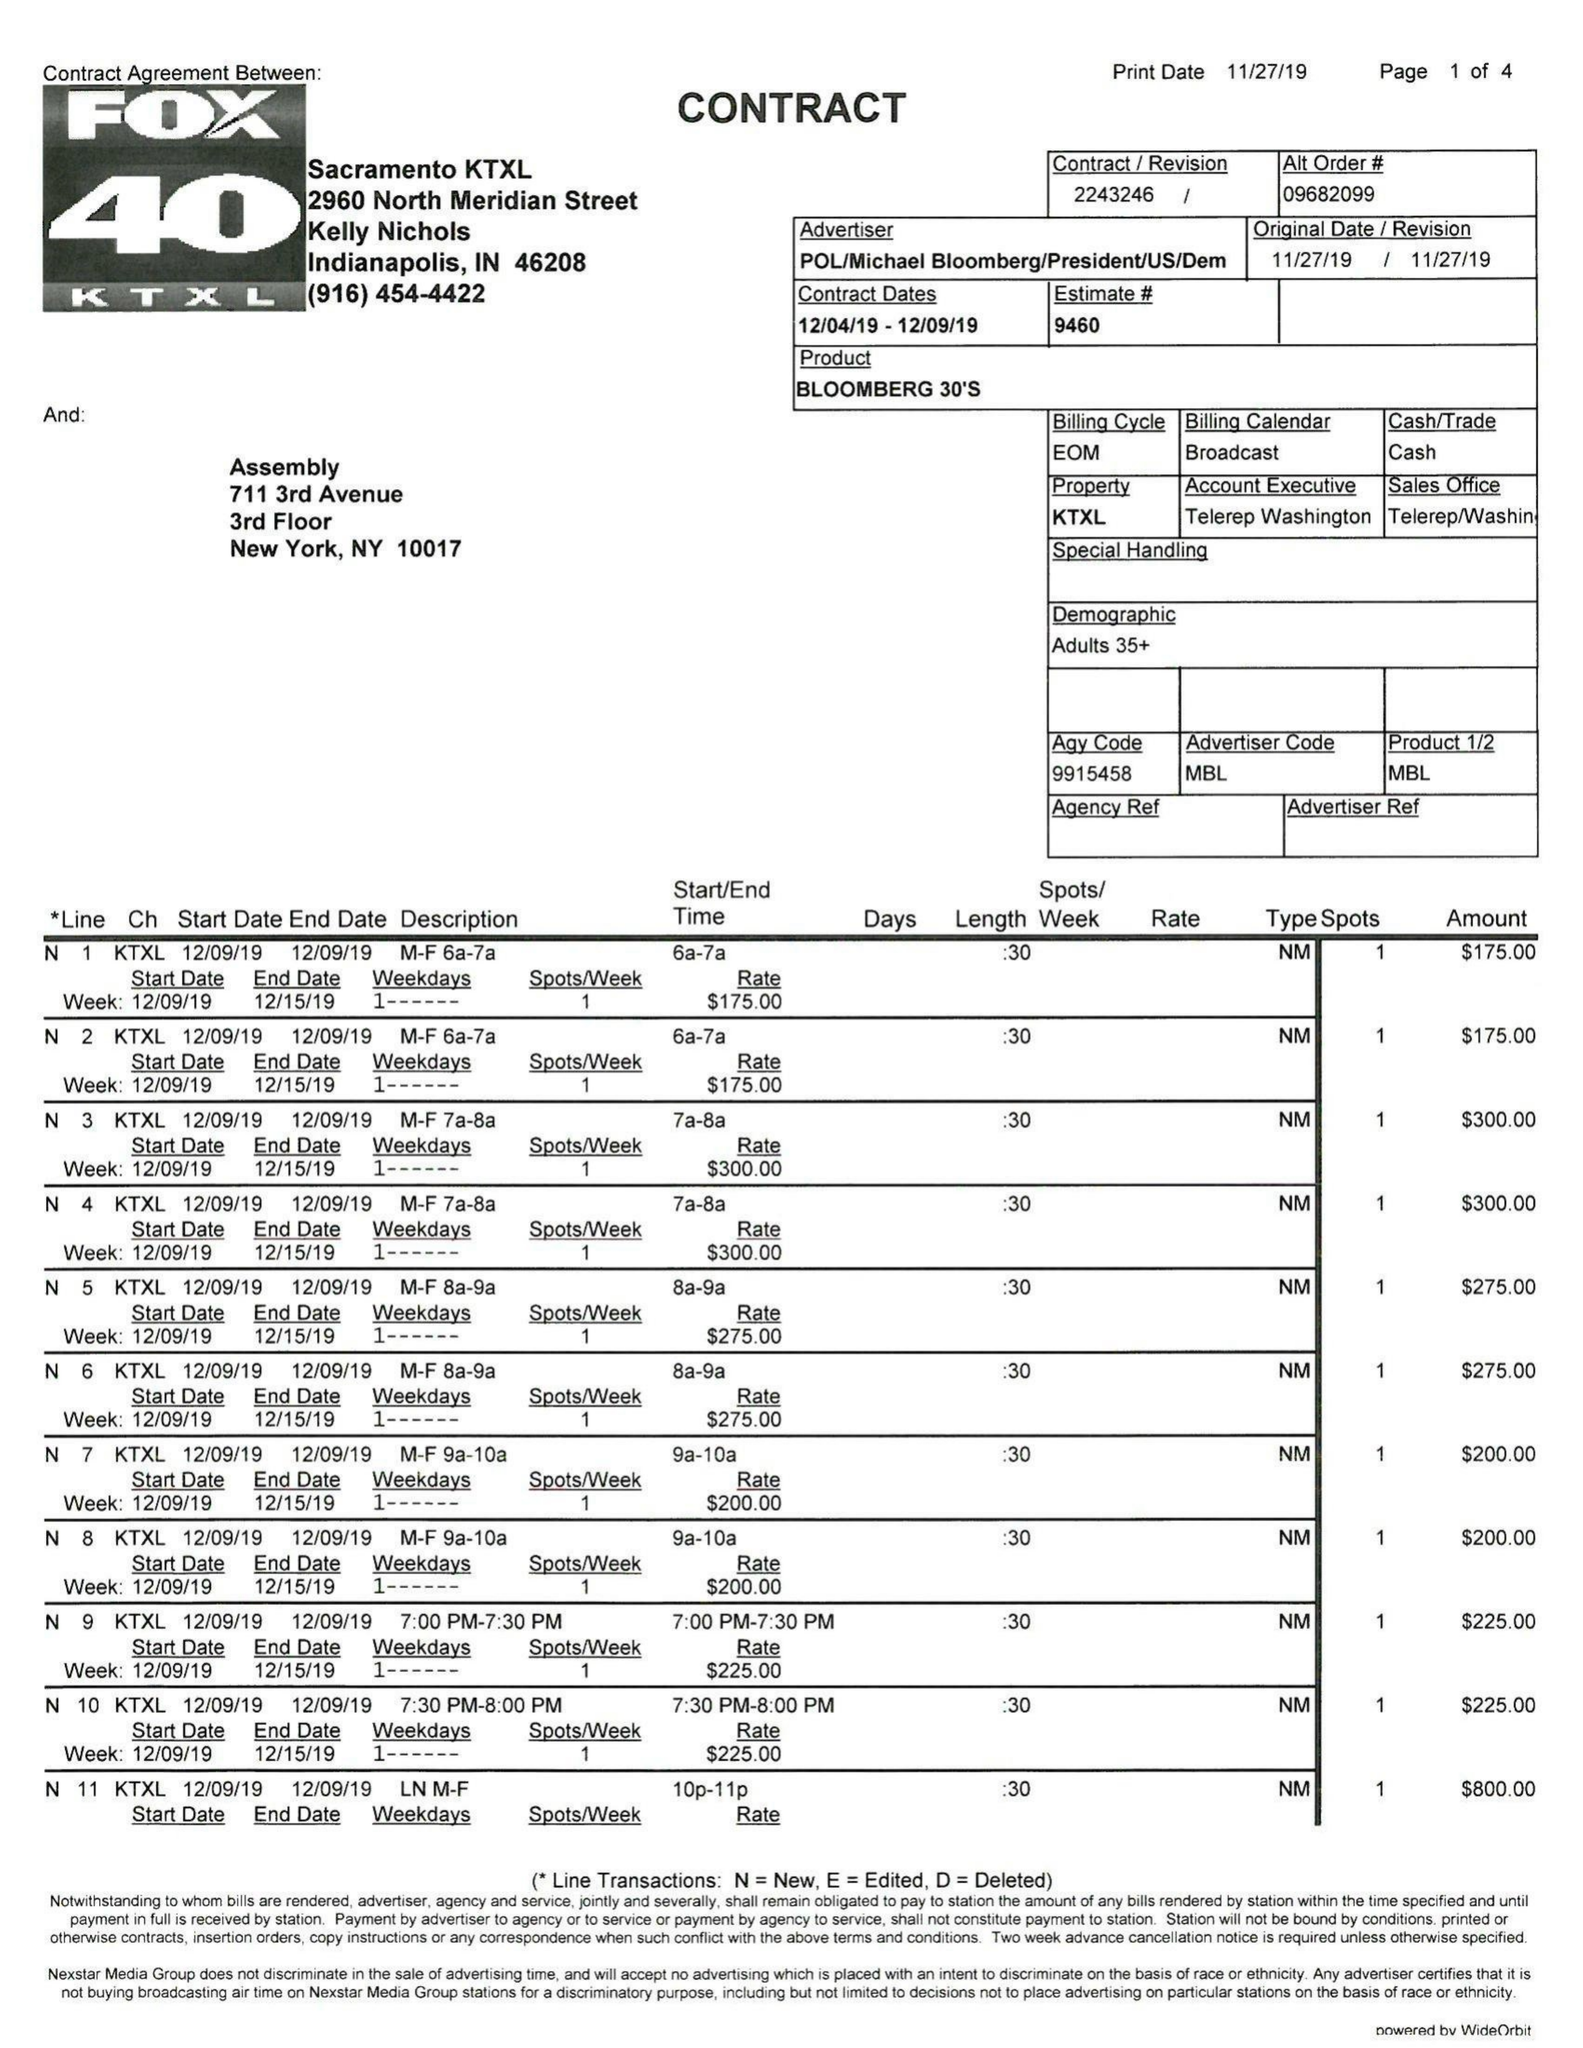What is the value for the contract_num?
Answer the question using a single word or phrase. 2243246 